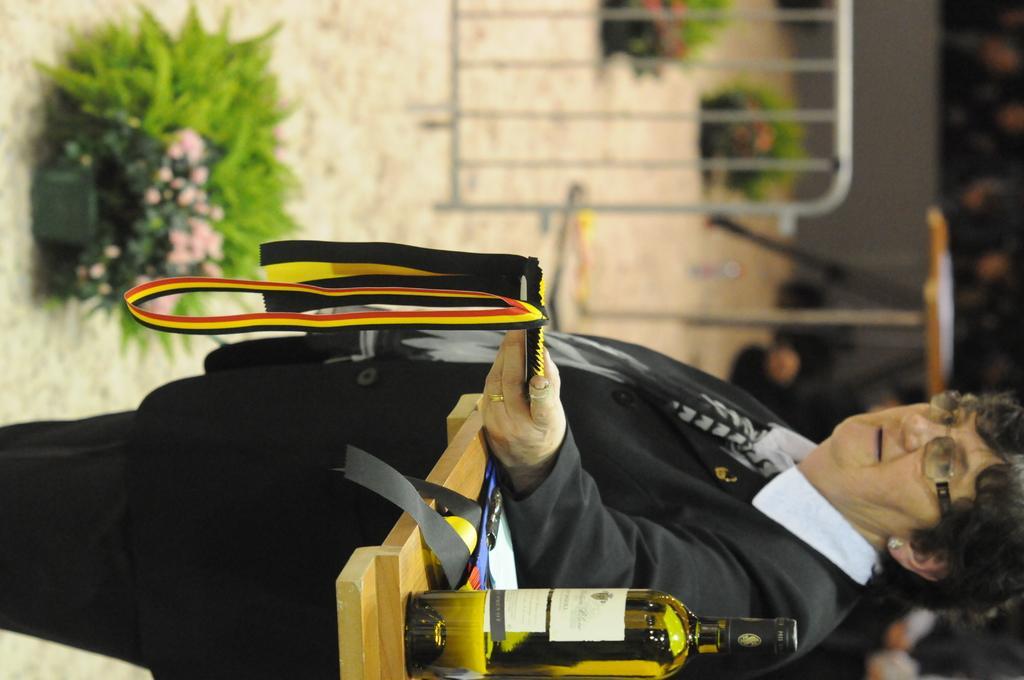Can you describe this image briefly? In this image we can see a lady wearing specs. And she is holding something in the hand. Near to her there is a table. On the table there is a bottle and some other items. In the back there is a pot with plant. Also there is railing, stand. And it is looking blur in the background. 